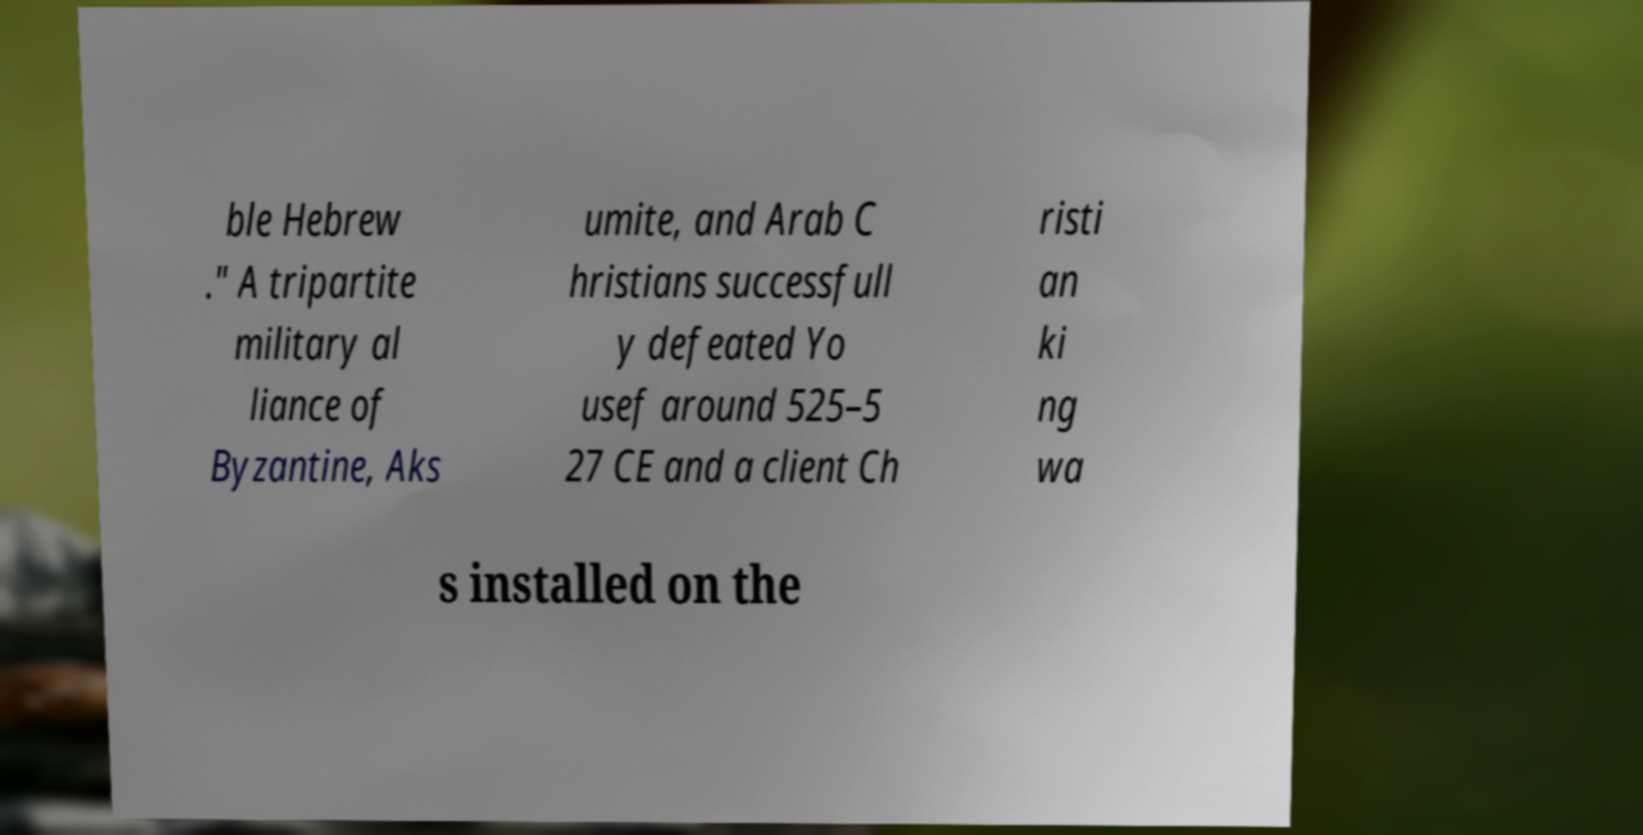Can you read and provide the text displayed in the image?This photo seems to have some interesting text. Can you extract and type it out for me? ble Hebrew ." A tripartite military al liance of Byzantine, Aks umite, and Arab C hristians successfull y defeated Yo usef around 525–5 27 CE and a client Ch risti an ki ng wa s installed on the 